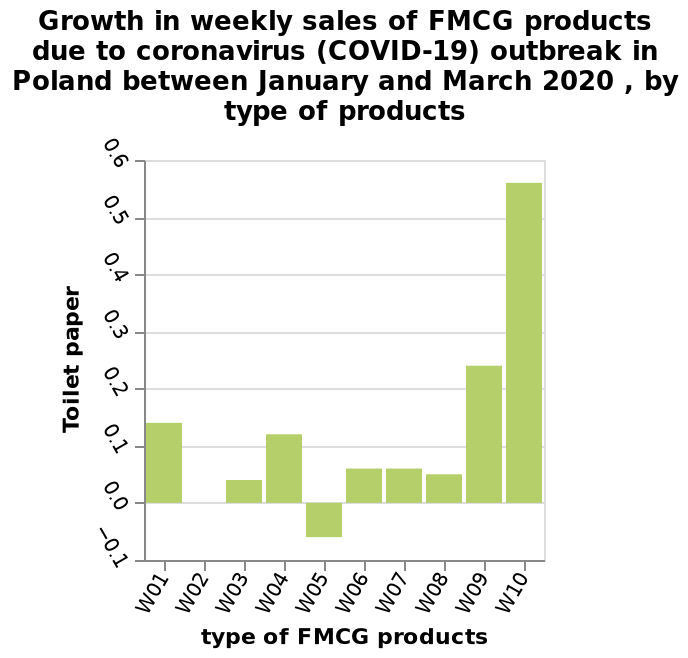<image>
What is the name of the chart described?  The chart described is a bar chart. What is being measured on the x-axis of the bar chart? The x-axis of the bar chart measures different types of FMCG products. 